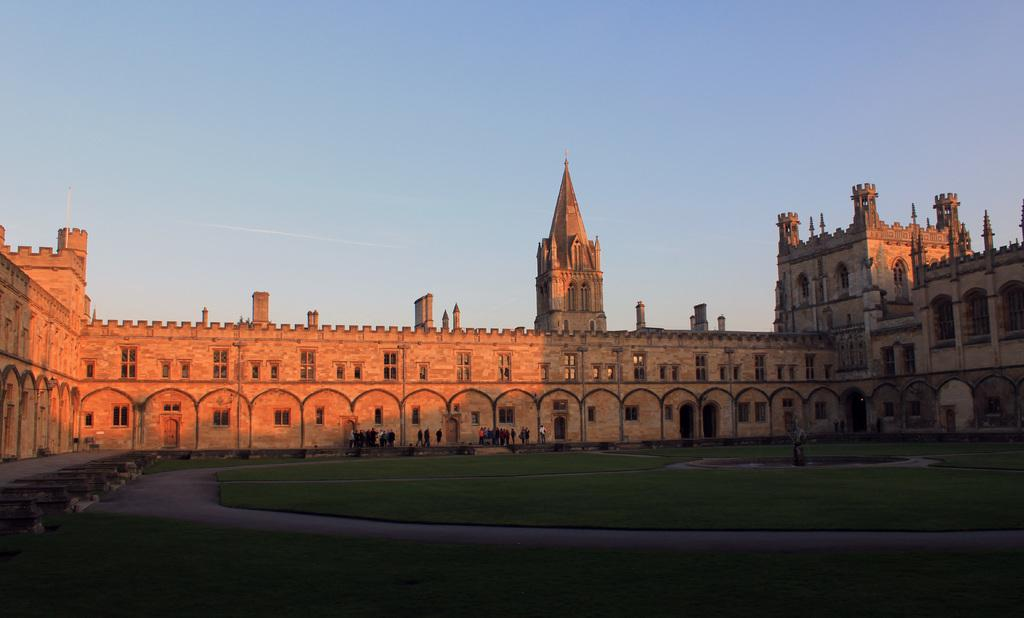What type of structure is present in the image? There is a building in the image. What feature can be seen on the building? The building has windows. What type of vegetation is present on the ground in the image? There is grass on the ground in the image. What can be used for walking or traveling in the image? There is a path or way in the image. Who or what is present in the image? There are people standing in the image. What is visible at the top of the image? The sky is visible at the top of the image. What type of sweater is being worn by the building in the image? There is no sweater present in the image, as the subject is a building and not a person. 